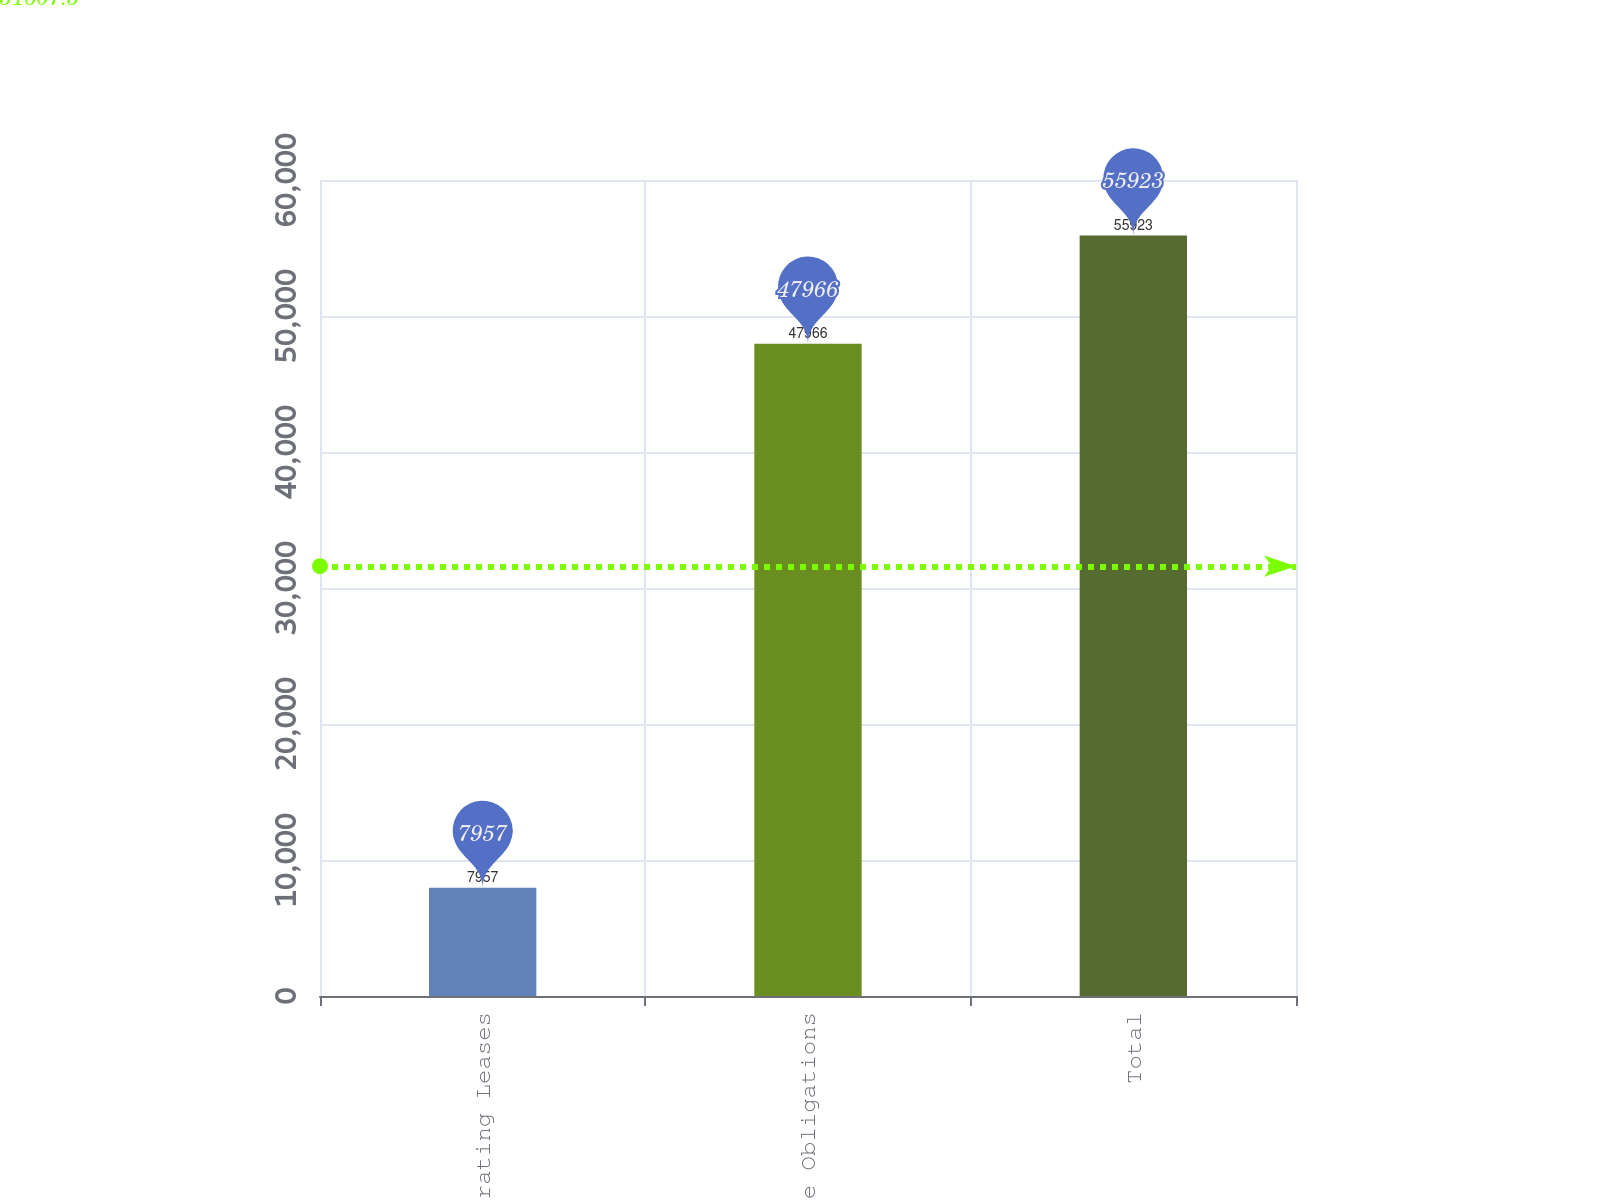Convert chart to OTSL. <chart><loc_0><loc_0><loc_500><loc_500><bar_chart><fcel>Operating Leases<fcel>Purchase Obligations<fcel>Total<nl><fcel>7957<fcel>47966<fcel>55923<nl></chart> 